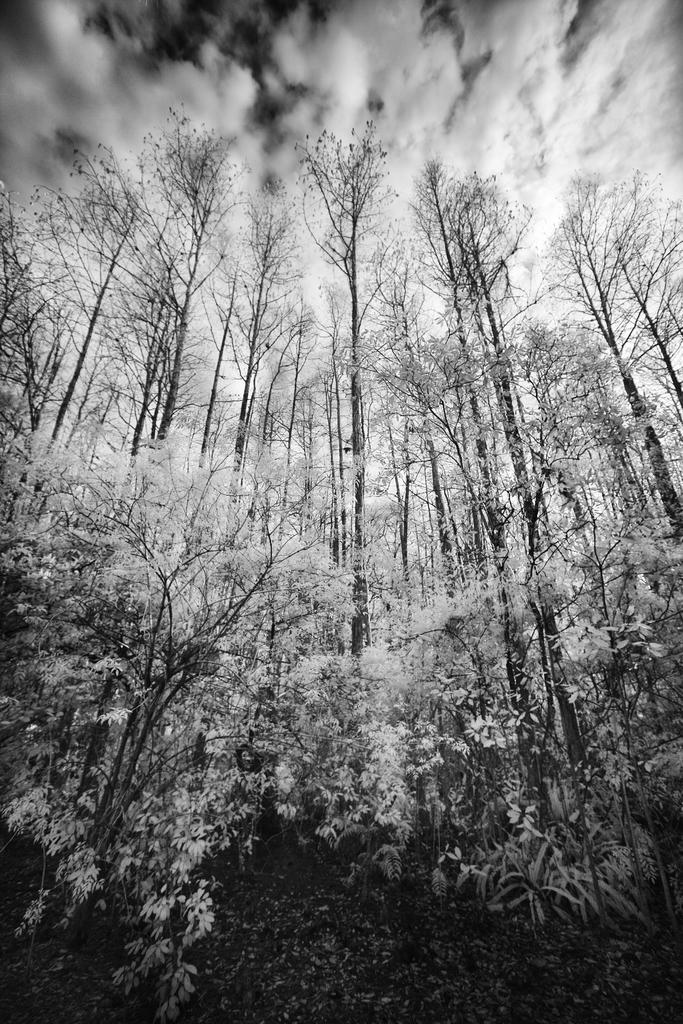Describe this image in one or two sentences. This picture might be taken in a forest, in this picture in the foreground there are some trees. On the top of the image there is sky. 